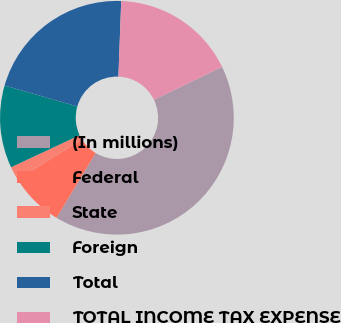<chart> <loc_0><loc_0><loc_500><loc_500><pie_chart><fcel>(In millions)<fcel>Federal<fcel>State<fcel>Foreign<fcel>Total<fcel>TOTAL INCOME TAX EXPENSE<nl><fcel>40.81%<fcel>7.52%<fcel>1.88%<fcel>11.41%<fcel>21.14%<fcel>17.24%<nl></chart> 